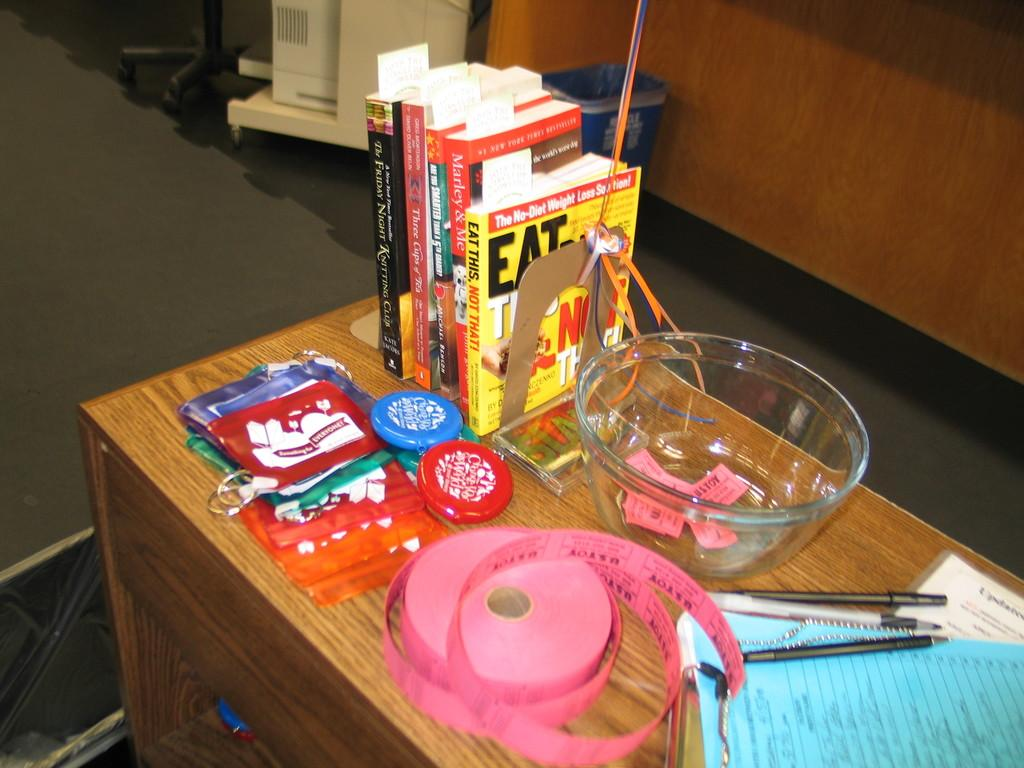<image>
Render a clear and concise summary of the photo. A book titled Eat this, Not that is being held up with a book end. 